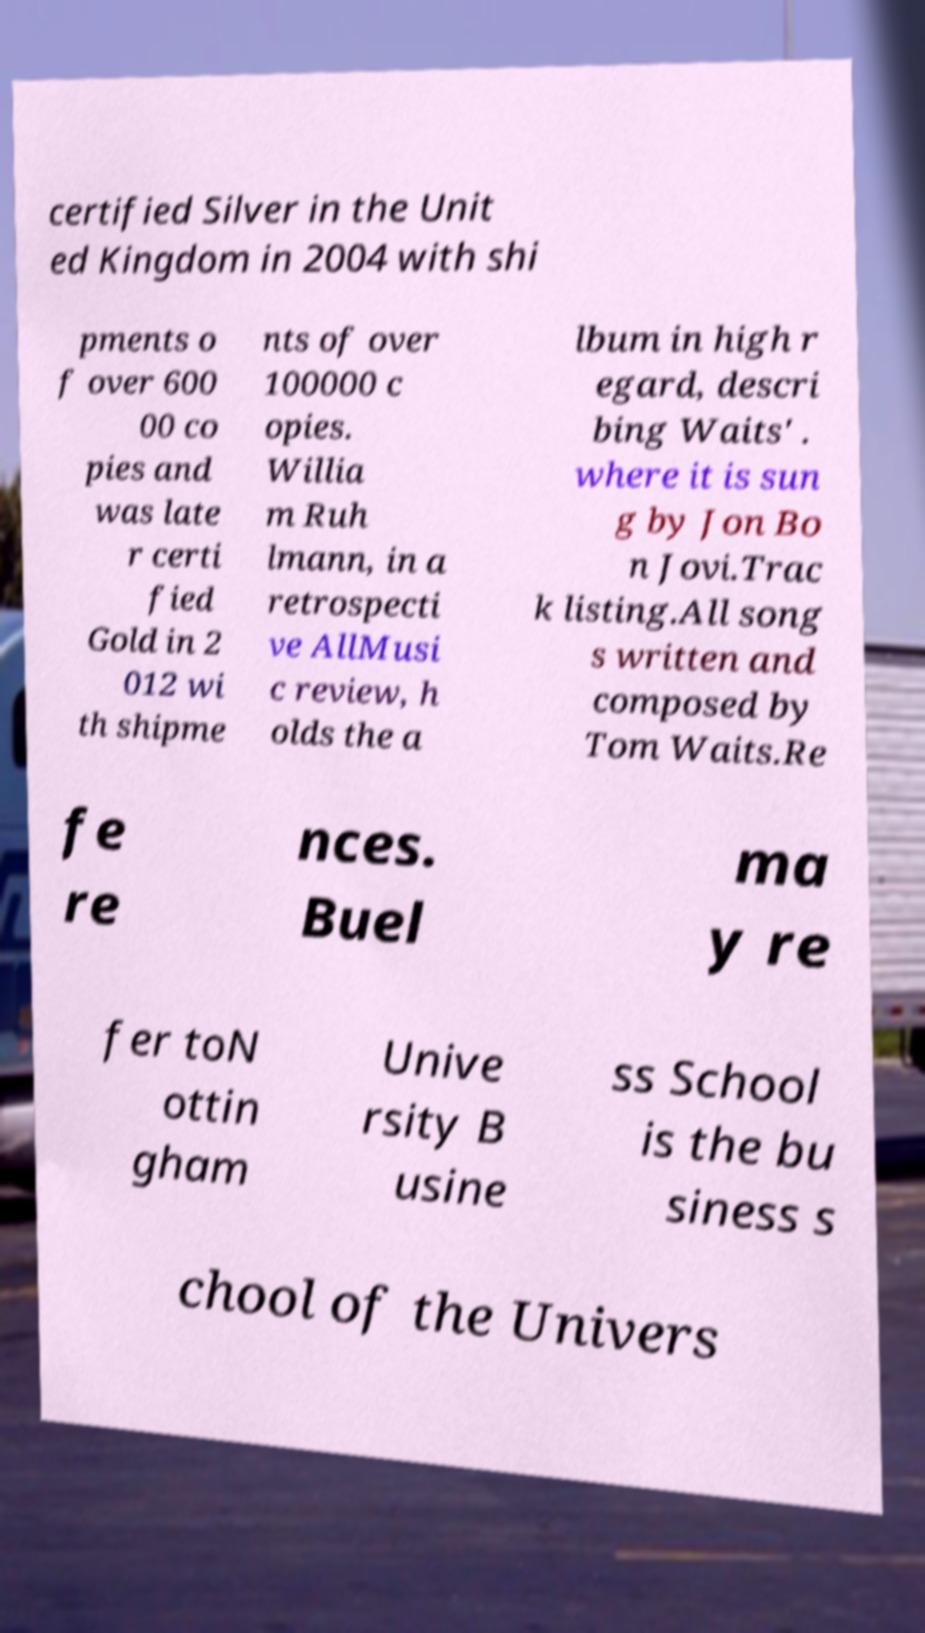Please identify and transcribe the text found in this image. certified Silver in the Unit ed Kingdom in 2004 with shi pments o f over 600 00 co pies and was late r certi fied Gold in 2 012 wi th shipme nts of over 100000 c opies. Willia m Ruh lmann, in a retrospecti ve AllMusi c review, h olds the a lbum in high r egard, descri bing Waits' . where it is sun g by Jon Bo n Jovi.Trac k listing.All song s written and composed by Tom Waits.Re fe re nces. Buel ma y re fer toN ottin gham Unive rsity B usine ss School is the bu siness s chool of the Univers 